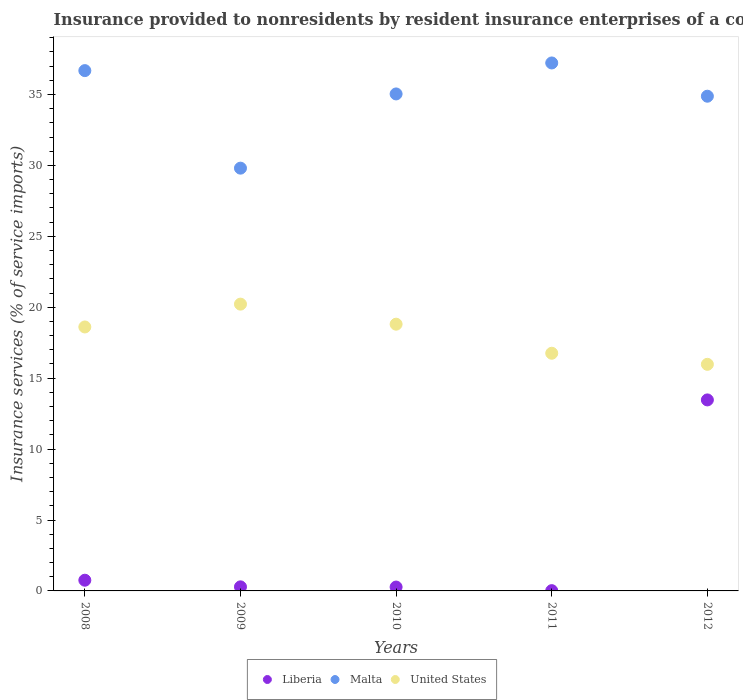Is the number of dotlines equal to the number of legend labels?
Your answer should be compact. Yes. What is the insurance provided to nonresidents in Malta in 2011?
Keep it short and to the point. 37.23. Across all years, what is the maximum insurance provided to nonresidents in Malta?
Make the answer very short. 37.23. Across all years, what is the minimum insurance provided to nonresidents in Liberia?
Give a very brief answer. 0.02. What is the total insurance provided to nonresidents in Liberia in the graph?
Your answer should be compact. 14.8. What is the difference between the insurance provided to nonresidents in Liberia in 2011 and that in 2012?
Your answer should be very brief. -13.45. What is the difference between the insurance provided to nonresidents in United States in 2008 and the insurance provided to nonresidents in Liberia in 2009?
Your answer should be compact. 18.32. What is the average insurance provided to nonresidents in Liberia per year?
Keep it short and to the point. 2.96. In the year 2011, what is the difference between the insurance provided to nonresidents in Malta and insurance provided to nonresidents in United States?
Offer a very short reply. 20.47. What is the ratio of the insurance provided to nonresidents in United States in 2008 to that in 2010?
Provide a succinct answer. 0.99. Is the difference between the insurance provided to nonresidents in Malta in 2008 and 2011 greater than the difference between the insurance provided to nonresidents in United States in 2008 and 2011?
Ensure brevity in your answer.  No. What is the difference between the highest and the second highest insurance provided to nonresidents in Malta?
Ensure brevity in your answer.  0.54. What is the difference between the highest and the lowest insurance provided to nonresidents in United States?
Provide a succinct answer. 4.24. Is it the case that in every year, the sum of the insurance provided to nonresidents in Malta and insurance provided to nonresidents in United States  is greater than the insurance provided to nonresidents in Liberia?
Your response must be concise. Yes. Does the insurance provided to nonresidents in United States monotonically increase over the years?
Give a very brief answer. No. Is the insurance provided to nonresidents in United States strictly greater than the insurance provided to nonresidents in Malta over the years?
Make the answer very short. No. How many dotlines are there?
Keep it short and to the point. 3. How many years are there in the graph?
Offer a very short reply. 5. Where does the legend appear in the graph?
Your answer should be very brief. Bottom center. How many legend labels are there?
Your answer should be compact. 3. What is the title of the graph?
Make the answer very short. Insurance provided to nonresidents by resident insurance enterprises of a country. What is the label or title of the X-axis?
Offer a terse response. Years. What is the label or title of the Y-axis?
Your answer should be very brief. Insurance services (% of service imports). What is the Insurance services (% of service imports) in Liberia in 2008?
Your answer should be compact. 0.75. What is the Insurance services (% of service imports) in Malta in 2008?
Make the answer very short. 36.69. What is the Insurance services (% of service imports) of United States in 2008?
Offer a very short reply. 18.61. What is the Insurance services (% of service imports) of Liberia in 2009?
Provide a short and direct response. 0.29. What is the Insurance services (% of service imports) in Malta in 2009?
Give a very brief answer. 29.81. What is the Insurance services (% of service imports) in United States in 2009?
Provide a short and direct response. 20.22. What is the Insurance services (% of service imports) of Liberia in 2010?
Give a very brief answer. 0.27. What is the Insurance services (% of service imports) in Malta in 2010?
Keep it short and to the point. 35.04. What is the Insurance services (% of service imports) of United States in 2010?
Your answer should be very brief. 18.81. What is the Insurance services (% of service imports) of Liberia in 2011?
Keep it short and to the point. 0.02. What is the Insurance services (% of service imports) of Malta in 2011?
Your answer should be very brief. 37.23. What is the Insurance services (% of service imports) of United States in 2011?
Your answer should be very brief. 16.76. What is the Insurance services (% of service imports) in Liberia in 2012?
Your response must be concise. 13.47. What is the Insurance services (% of service imports) in Malta in 2012?
Provide a short and direct response. 34.88. What is the Insurance services (% of service imports) in United States in 2012?
Provide a short and direct response. 15.98. Across all years, what is the maximum Insurance services (% of service imports) of Liberia?
Give a very brief answer. 13.47. Across all years, what is the maximum Insurance services (% of service imports) in Malta?
Your answer should be very brief. 37.23. Across all years, what is the maximum Insurance services (% of service imports) in United States?
Your answer should be very brief. 20.22. Across all years, what is the minimum Insurance services (% of service imports) of Liberia?
Give a very brief answer. 0.02. Across all years, what is the minimum Insurance services (% of service imports) in Malta?
Your response must be concise. 29.81. Across all years, what is the minimum Insurance services (% of service imports) in United States?
Offer a terse response. 15.98. What is the total Insurance services (% of service imports) of Liberia in the graph?
Your response must be concise. 14.8. What is the total Insurance services (% of service imports) in Malta in the graph?
Offer a very short reply. 173.64. What is the total Insurance services (% of service imports) in United States in the graph?
Your response must be concise. 90.37. What is the difference between the Insurance services (% of service imports) of Liberia in 2008 and that in 2009?
Keep it short and to the point. 0.47. What is the difference between the Insurance services (% of service imports) in Malta in 2008 and that in 2009?
Your answer should be very brief. 6.88. What is the difference between the Insurance services (% of service imports) of United States in 2008 and that in 2009?
Keep it short and to the point. -1.61. What is the difference between the Insurance services (% of service imports) in Liberia in 2008 and that in 2010?
Keep it short and to the point. 0.48. What is the difference between the Insurance services (% of service imports) of Malta in 2008 and that in 2010?
Your answer should be compact. 1.64. What is the difference between the Insurance services (% of service imports) in United States in 2008 and that in 2010?
Provide a short and direct response. -0.2. What is the difference between the Insurance services (% of service imports) of Liberia in 2008 and that in 2011?
Provide a short and direct response. 0.74. What is the difference between the Insurance services (% of service imports) of Malta in 2008 and that in 2011?
Offer a very short reply. -0.54. What is the difference between the Insurance services (% of service imports) in United States in 2008 and that in 2011?
Ensure brevity in your answer.  1.85. What is the difference between the Insurance services (% of service imports) of Liberia in 2008 and that in 2012?
Provide a short and direct response. -12.71. What is the difference between the Insurance services (% of service imports) in Malta in 2008 and that in 2012?
Your answer should be compact. 1.8. What is the difference between the Insurance services (% of service imports) of United States in 2008 and that in 2012?
Make the answer very short. 2.63. What is the difference between the Insurance services (% of service imports) in Liberia in 2009 and that in 2010?
Ensure brevity in your answer.  0.01. What is the difference between the Insurance services (% of service imports) in Malta in 2009 and that in 2010?
Provide a short and direct response. -5.23. What is the difference between the Insurance services (% of service imports) of United States in 2009 and that in 2010?
Provide a succinct answer. 1.41. What is the difference between the Insurance services (% of service imports) in Liberia in 2009 and that in 2011?
Ensure brevity in your answer.  0.27. What is the difference between the Insurance services (% of service imports) in Malta in 2009 and that in 2011?
Keep it short and to the point. -7.42. What is the difference between the Insurance services (% of service imports) in United States in 2009 and that in 2011?
Give a very brief answer. 3.46. What is the difference between the Insurance services (% of service imports) of Liberia in 2009 and that in 2012?
Your answer should be compact. -13.18. What is the difference between the Insurance services (% of service imports) of Malta in 2009 and that in 2012?
Keep it short and to the point. -5.07. What is the difference between the Insurance services (% of service imports) of United States in 2009 and that in 2012?
Offer a very short reply. 4.24. What is the difference between the Insurance services (% of service imports) in Liberia in 2010 and that in 2011?
Your answer should be compact. 0.25. What is the difference between the Insurance services (% of service imports) in Malta in 2010 and that in 2011?
Keep it short and to the point. -2.18. What is the difference between the Insurance services (% of service imports) of United States in 2010 and that in 2011?
Offer a very short reply. 2.05. What is the difference between the Insurance services (% of service imports) in Liberia in 2010 and that in 2012?
Keep it short and to the point. -13.19. What is the difference between the Insurance services (% of service imports) of Malta in 2010 and that in 2012?
Ensure brevity in your answer.  0.16. What is the difference between the Insurance services (% of service imports) in United States in 2010 and that in 2012?
Offer a terse response. 2.83. What is the difference between the Insurance services (% of service imports) in Liberia in 2011 and that in 2012?
Your answer should be compact. -13.45. What is the difference between the Insurance services (% of service imports) in Malta in 2011 and that in 2012?
Your answer should be compact. 2.34. What is the difference between the Insurance services (% of service imports) in United States in 2011 and that in 2012?
Provide a succinct answer. 0.78. What is the difference between the Insurance services (% of service imports) in Liberia in 2008 and the Insurance services (% of service imports) in Malta in 2009?
Offer a terse response. -29.05. What is the difference between the Insurance services (% of service imports) of Liberia in 2008 and the Insurance services (% of service imports) of United States in 2009?
Your answer should be very brief. -19.47. What is the difference between the Insurance services (% of service imports) of Malta in 2008 and the Insurance services (% of service imports) of United States in 2009?
Offer a terse response. 16.47. What is the difference between the Insurance services (% of service imports) of Liberia in 2008 and the Insurance services (% of service imports) of Malta in 2010?
Your answer should be compact. -34.29. What is the difference between the Insurance services (% of service imports) of Liberia in 2008 and the Insurance services (% of service imports) of United States in 2010?
Your response must be concise. -18.05. What is the difference between the Insurance services (% of service imports) in Malta in 2008 and the Insurance services (% of service imports) in United States in 2010?
Provide a short and direct response. 17.88. What is the difference between the Insurance services (% of service imports) of Liberia in 2008 and the Insurance services (% of service imports) of Malta in 2011?
Provide a short and direct response. -36.47. What is the difference between the Insurance services (% of service imports) in Liberia in 2008 and the Insurance services (% of service imports) in United States in 2011?
Offer a terse response. -16. What is the difference between the Insurance services (% of service imports) of Malta in 2008 and the Insurance services (% of service imports) of United States in 2011?
Provide a succinct answer. 19.93. What is the difference between the Insurance services (% of service imports) in Liberia in 2008 and the Insurance services (% of service imports) in Malta in 2012?
Ensure brevity in your answer.  -34.13. What is the difference between the Insurance services (% of service imports) of Liberia in 2008 and the Insurance services (% of service imports) of United States in 2012?
Your answer should be compact. -15.22. What is the difference between the Insurance services (% of service imports) of Malta in 2008 and the Insurance services (% of service imports) of United States in 2012?
Your answer should be compact. 20.71. What is the difference between the Insurance services (% of service imports) of Liberia in 2009 and the Insurance services (% of service imports) of Malta in 2010?
Your answer should be very brief. -34.75. What is the difference between the Insurance services (% of service imports) of Liberia in 2009 and the Insurance services (% of service imports) of United States in 2010?
Provide a short and direct response. -18.52. What is the difference between the Insurance services (% of service imports) in Malta in 2009 and the Insurance services (% of service imports) in United States in 2010?
Make the answer very short. 11. What is the difference between the Insurance services (% of service imports) in Liberia in 2009 and the Insurance services (% of service imports) in Malta in 2011?
Your answer should be very brief. -36.94. What is the difference between the Insurance services (% of service imports) of Liberia in 2009 and the Insurance services (% of service imports) of United States in 2011?
Your answer should be compact. -16.47. What is the difference between the Insurance services (% of service imports) in Malta in 2009 and the Insurance services (% of service imports) in United States in 2011?
Your answer should be compact. 13.05. What is the difference between the Insurance services (% of service imports) in Liberia in 2009 and the Insurance services (% of service imports) in Malta in 2012?
Ensure brevity in your answer.  -34.59. What is the difference between the Insurance services (% of service imports) in Liberia in 2009 and the Insurance services (% of service imports) in United States in 2012?
Make the answer very short. -15.69. What is the difference between the Insurance services (% of service imports) of Malta in 2009 and the Insurance services (% of service imports) of United States in 2012?
Keep it short and to the point. 13.83. What is the difference between the Insurance services (% of service imports) of Liberia in 2010 and the Insurance services (% of service imports) of Malta in 2011?
Your answer should be very brief. -36.95. What is the difference between the Insurance services (% of service imports) of Liberia in 2010 and the Insurance services (% of service imports) of United States in 2011?
Offer a terse response. -16.48. What is the difference between the Insurance services (% of service imports) of Malta in 2010 and the Insurance services (% of service imports) of United States in 2011?
Your answer should be very brief. 18.28. What is the difference between the Insurance services (% of service imports) in Liberia in 2010 and the Insurance services (% of service imports) in Malta in 2012?
Provide a short and direct response. -34.61. What is the difference between the Insurance services (% of service imports) in Liberia in 2010 and the Insurance services (% of service imports) in United States in 2012?
Provide a short and direct response. -15.7. What is the difference between the Insurance services (% of service imports) of Malta in 2010 and the Insurance services (% of service imports) of United States in 2012?
Your response must be concise. 19.06. What is the difference between the Insurance services (% of service imports) of Liberia in 2011 and the Insurance services (% of service imports) of Malta in 2012?
Keep it short and to the point. -34.86. What is the difference between the Insurance services (% of service imports) in Liberia in 2011 and the Insurance services (% of service imports) in United States in 2012?
Keep it short and to the point. -15.96. What is the difference between the Insurance services (% of service imports) of Malta in 2011 and the Insurance services (% of service imports) of United States in 2012?
Make the answer very short. 21.25. What is the average Insurance services (% of service imports) in Liberia per year?
Ensure brevity in your answer.  2.96. What is the average Insurance services (% of service imports) in Malta per year?
Provide a succinct answer. 34.73. What is the average Insurance services (% of service imports) in United States per year?
Provide a short and direct response. 18.07. In the year 2008, what is the difference between the Insurance services (% of service imports) of Liberia and Insurance services (% of service imports) of Malta?
Keep it short and to the point. -35.93. In the year 2008, what is the difference between the Insurance services (% of service imports) of Liberia and Insurance services (% of service imports) of United States?
Offer a terse response. -17.86. In the year 2008, what is the difference between the Insurance services (% of service imports) of Malta and Insurance services (% of service imports) of United States?
Offer a very short reply. 18.07. In the year 2009, what is the difference between the Insurance services (% of service imports) of Liberia and Insurance services (% of service imports) of Malta?
Make the answer very short. -29.52. In the year 2009, what is the difference between the Insurance services (% of service imports) of Liberia and Insurance services (% of service imports) of United States?
Make the answer very short. -19.93. In the year 2009, what is the difference between the Insurance services (% of service imports) of Malta and Insurance services (% of service imports) of United States?
Give a very brief answer. 9.59. In the year 2010, what is the difference between the Insurance services (% of service imports) in Liberia and Insurance services (% of service imports) in Malta?
Make the answer very short. -34.77. In the year 2010, what is the difference between the Insurance services (% of service imports) in Liberia and Insurance services (% of service imports) in United States?
Keep it short and to the point. -18.53. In the year 2010, what is the difference between the Insurance services (% of service imports) of Malta and Insurance services (% of service imports) of United States?
Provide a succinct answer. 16.23. In the year 2011, what is the difference between the Insurance services (% of service imports) of Liberia and Insurance services (% of service imports) of Malta?
Your answer should be compact. -37.21. In the year 2011, what is the difference between the Insurance services (% of service imports) in Liberia and Insurance services (% of service imports) in United States?
Give a very brief answer. -16.74. In the year 2011, what is the difference between the Insurance services (% of service imports) of Malta and Insurance services (% of service imports) of United States?
Keep it short and to the point. 20.47. In the year 2012, what is the difference between the Insurance services (% of service imports) of Liberia and Insurance services (% of service imports) of Malta?
Keep it short and to the point. -21.41. In the year 2012, what is the difference between the Insurance services (% of service imports) in Liberia and Insurance services (% of service imports) in United States?
Your answer should be compact. -2.51. In the year 2012, what is the difference between the Insurance services (% of service imports) of Malta and Insurance services (% of service imports) of United States?
Give a very brief answer. 18.9. What is the ratio of the Insurance services (% of service imports) in Liberia in 2008 to that in 2009?
Keep it short and to the point. 2.63. What is the ratio of the Insurance services (% of service imports) of Malta in 2008 to that in 2009?
Keep it short and to the point. 1.23. What is the ratio of the Insurance services (% of service imports) of United States in 2008 to that in 2009?
Keep it short and to the point. 0.92. What is the ratio of the Insurance services (% of service imports) in Liberia in 2008 to that in 2010?
Your response must be concise. 2.77. What is the ratio of the Insurance services (% of service imports) in Malta in 2008 to that in 2010?
Offer a very short reply. 1.05. What is the ratio of the Insurance services (% of service imports) of United States in 2008 to that in 2010?
Your answer should be very brief. 0.99. What is the ratio of the Insurance services (% of service imports) of Liberia in 2008 to that in 2011?
Your response must be concise. 38.9. What is the ratio of the Insurance services (% of service imports) in Malta in 2008 to that in 2011?
Keep it short and to the point. 0.99. What is the ratio of the Insurance services (% of service imports) in United States in 2008 to that in 2011?
Offer a terse response. 1.11. What is the ratio of the Insurance services (% of service imports) in Liberia in 2008 to that in 2012?
Offer a very short reply. 0.06. What is the ratio of the Insurance services (% of service imports) of Malta in 2008 to that in 2012?
Keep it short and to the point. 1.05. What is the ratio of the Insurance services (% of service imports) in United States in 2008 to that in 2012?
Provide a succinct answer. 1.16. What is the ratio of the Insurance services (% of service imports) in Liberia in 2009 to that in 2010?
Your answer should be very brief. 1.05. What is the ratio of the Insurance services (% of service imports) in Malta in 2009 to that in 2010?
Ensure brevity in your answer.  0.85. What is the ratio of the Insurance services (% of service imports) of United States in 2009 to that in 2010?
Give a very brief answer. 1.08. What is the ratio of the Insurance services (% of service imports) in Liberia in 2009 to that in 2011?
Offer a very short reply. 14.8. What is the ratio of the Insurance services (% of service imports) in Malta in 2009 to that in 2011?
Ensure brevity in your answer.  0.8. What is the ratio of the Insurance services (% of service imports) in United States in 2009 to that in 2011?
Your answer should be very brief. 1.21. What is the ratio of the Insurance services (% of service imports) in Liberia in 2009 to that in 2012?
Keep it short and to the point. 0.02. What is the ratio of the Insurance services (% of service imports) of Malta in 2009 to that in 2012?
Your answer should be very brief. 0.85. What is the ratio of the Insurance services (% of service imports) in United States in 2009 to that in 2012?
Provide a short and direct response. 1.27. What is the ratio of the Insurance services (% of service imports) in Liberia in 2010 to that in 2011?
Provide a succinct answer. 14.07. What is the ratio of the Insurance services (% of service imports) in Malta in 2010 to that in 2011?
Ensure brevity in your answer.  0.94. What is the ratio of the Insurance services (% of service imports) in United States in 2010 to that in 2011?
Your answer should be very brief. 1.12. What is the ratio of the Insurance services (% of service imports) in Liberia in 2010 to that in 2012?
Ensure brevity in your answer.  0.02. What is the ratio of the Insurance services (% of service imports) of United States in 2010 to that in 2012?
Make the answer very short. 1.18. What is the ratio of the Insurance services (% of service imports) in Liberia in 2011 to that in 2012?
Your response must be concise. 0. What is the ratio of the Insurance services (% of service imports) in Malta in 2011 to that in 2012?
Make the answer very short. 1.07. What is the ratio of the Insurance services (% of service imports) in United States in 2011 to that in 2012?
Provide a short and direct response. 1.05. What is the difference between the highest and the second highest Insurance services (% of service imports) in Liberia?
Ensure brevity in your answer.  12.71. What is the difference between the highest and the second highest Insurance services (% of service imports) of Malta?
Offer a very short reply. 0.54. What is the difference between the highest and the second highest Insurance services (% of service imports) of United States?
Your response must be concise. 1.41. What is the difference between the highest and the lowest Insurance services (% of service imports) of Liberia?
Your response must be concise. 13.45. What is the difference between the highest and the lowest Insurance services (% of service imports) of Malta?
Ensure brevity in your answer.  7.42. What is the difference between the highest and the lowest Insurance services (% of service imports) in United States?
Offer a very short reply. 4.24. 